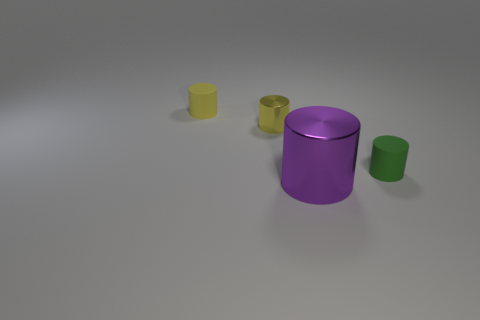What is the size of the other cylinder that is the same color as the small metallic cylinder?
Your response must be concise. Small. Is the tiny metallic thing the same color as the large shiny thing?
Keep it short and to the point. No. There is a metallic thing behind the tiny matte cylinder that is on the right side of the large purple cylinder; is there a small green rubber object behind it?
Your response must be concise. No. What number of yellow metal cylinders have the same size as the purple cylinder?
Give a very brief answer. 0. There is a rubber cylinder on the left side of the tiny green thing; is it the same size as the metal cylinder that is left of the large object?
Make the answer very short. Yes. What shape is the object that is both in front of the tiny yellow shiny cylinder and behind the large metal cylinder?
Offer a terse response. Cylinder. Is there a metallic cylinder of the same color as the big shiny thing?
Your answer should be compact. No. Are any yellow spheres visible?
Make the answer very short. No. There is a small matte object right of the yellow matte object; what color is it?
Give a very brief answer. Green. Is the size of the green rubber cylinder the same as the metal object behind the big purple cylinder?
Your answer should be compact. Yes. 